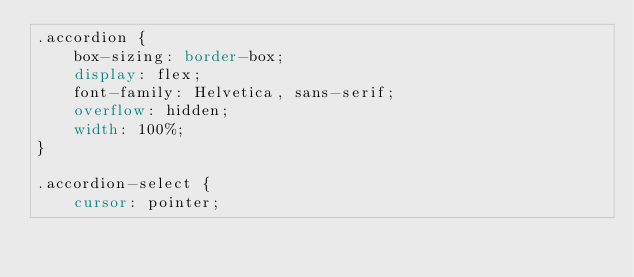<code> <loc_0><loc_0><loc_500><loc_500><_CSS_>.accordion {
    box-sizing: border-box;
    display: flex;
    font-family: Helvetica, sans-serif;
    overflow: hidden;
    width: 100%;
}

.accordion-select {
    cursor: pointer;</code> 